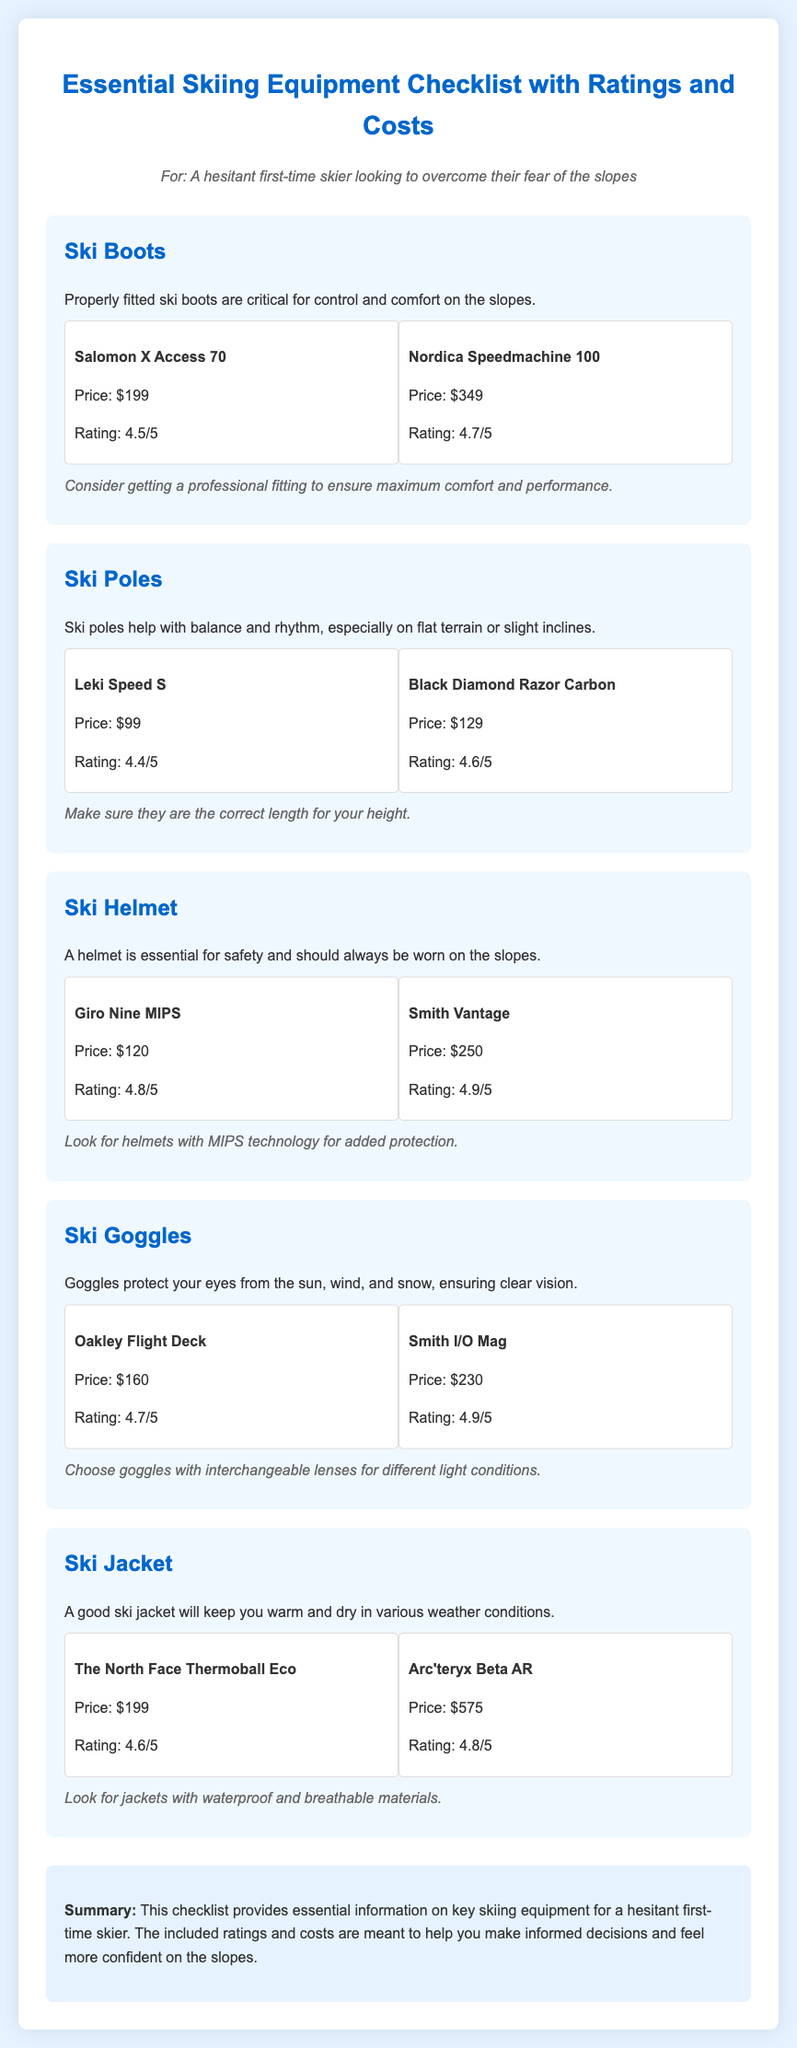What is the price of the Salomon X Access 70? The price of the Salomon X Access 70 is specifically listed in the document as $199.
Answer: $199 What is the highest rating for ski helmets in the checklist? The ratings for ski helmets in the checklist show that the Smith Vantage has the highest rating of 4.9/5.
Answer: 4.9/5 Which skiing equipment is essential for safety? The document explicitly states that a helmet is essential for safety while skiing.
Answer: Helmet How much does the Arc'teryx Beta AR ski jacket cost? The cost of the Arc'teryx Beta AR ski jacket is detailed in the document as $575.
Answer: $575 What feature should ski goggles have for varying light conditions? The document mentions that ski goggles should have interchangeable lenses for different light conditions.
Answer: Interchangeable lenses Which ski poles are priced at $129? Among the ski poles listed, the Black Diamond Razor Carbon is specified as being priced at $129.
Answer: Black Diamond Razor Carbon What should you consider when getting ski boots? The checklist notes that one should consider getting a professional fitting to ensure optimal comfort and performance with the ski boots.
Answer: Professional fitting Which ski helmet features MIPS technology? The document suggests looking for helmets with MIPS technology, specifically mentioning the Giro Nine MIPS.
Answer: Giro Nine MIPS What is the main purpose of ski poles according to the checklist? The checklist mentions that ski poles help with balance and rhythm, especially on flat terrain or slight inclines.
Answer: Balance and rhythm 